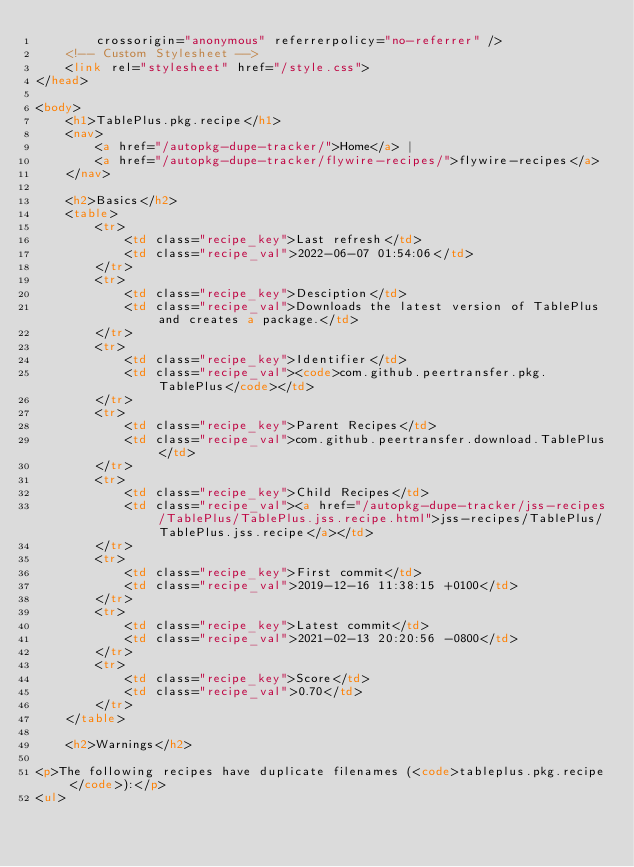<code> <loc_0><loc_0><loc_500><loc_500><_HTML_>        crossorigin="anonymous" referrerpolicy="no-referrer" />
    <!-- Custom Stylesheet -->
    <link rel="stylesheet" href="/style.css">
</head>

<body>
    <h1>TablePlus.pkg.recipe</h1>
    <nav>
        <a href="/autopkg-dupe-tracker/">Home</a> |
        <a href="/autopkg-dupe-tracker/flywire-recipes/">flywire-recipes</a>
    </nav>

    <h2>Basics</h2>
    <table>
        <tr>
            <td class="recipe_key">Last refresh</td>
            <td class="recipe_val">2022-06-07 01:54:06</td>
        </tr>
        <tr>
            <td class="recipe_key">Desciption</td>
            <td class="recipe_val">Downloads the latest version of TablePlus and creates a package.</td>
        </tr>
        <tr>
            <td class="recipe_key">Identifier</td>
            <td class="recipe_val"><code>com.github.peertransfer.pkg.TablePlus</code></td>
        </tr>
        <tr>
            <td class="recipe_key">Parent Recipes</td>
            <td class="recipe_val">com.github.peertransfer.download.TablePlus</td>
        </tr>
        <tr>
            <td class="recipe_key">Child Recipes</td>
            <td class="recipe_val"><a href="/autopkg-dupe-tracker/jss-recipes/TablePlus/TablePlus.jss.recipe.html">jss-recipes/TablePlus/TablePlus.jss.recipe</a></td>
        </tr>
        <tr>
            <td class="recipe_key">First commit</td>
            <td class="recipe_val">2019-12-16 11:38:15 +0100</td>
        </tr>
        <tr>
            <td class="recipe_key">Latest commit</td>
            <td class="recipe_val">2021-02-13 20:20:56 -0800</td>
        </tr>
        <tr>
            <td class="recipe_key">Score</td>
            <td class="recipe_val">0.70</td>
        </tr>
    </table>

    <h2>Warnings</h2>
    
<p>The following recipes have duplicate filenames (<code>tableplus.pkg.recipe</code>):</p>
<ul></code> 